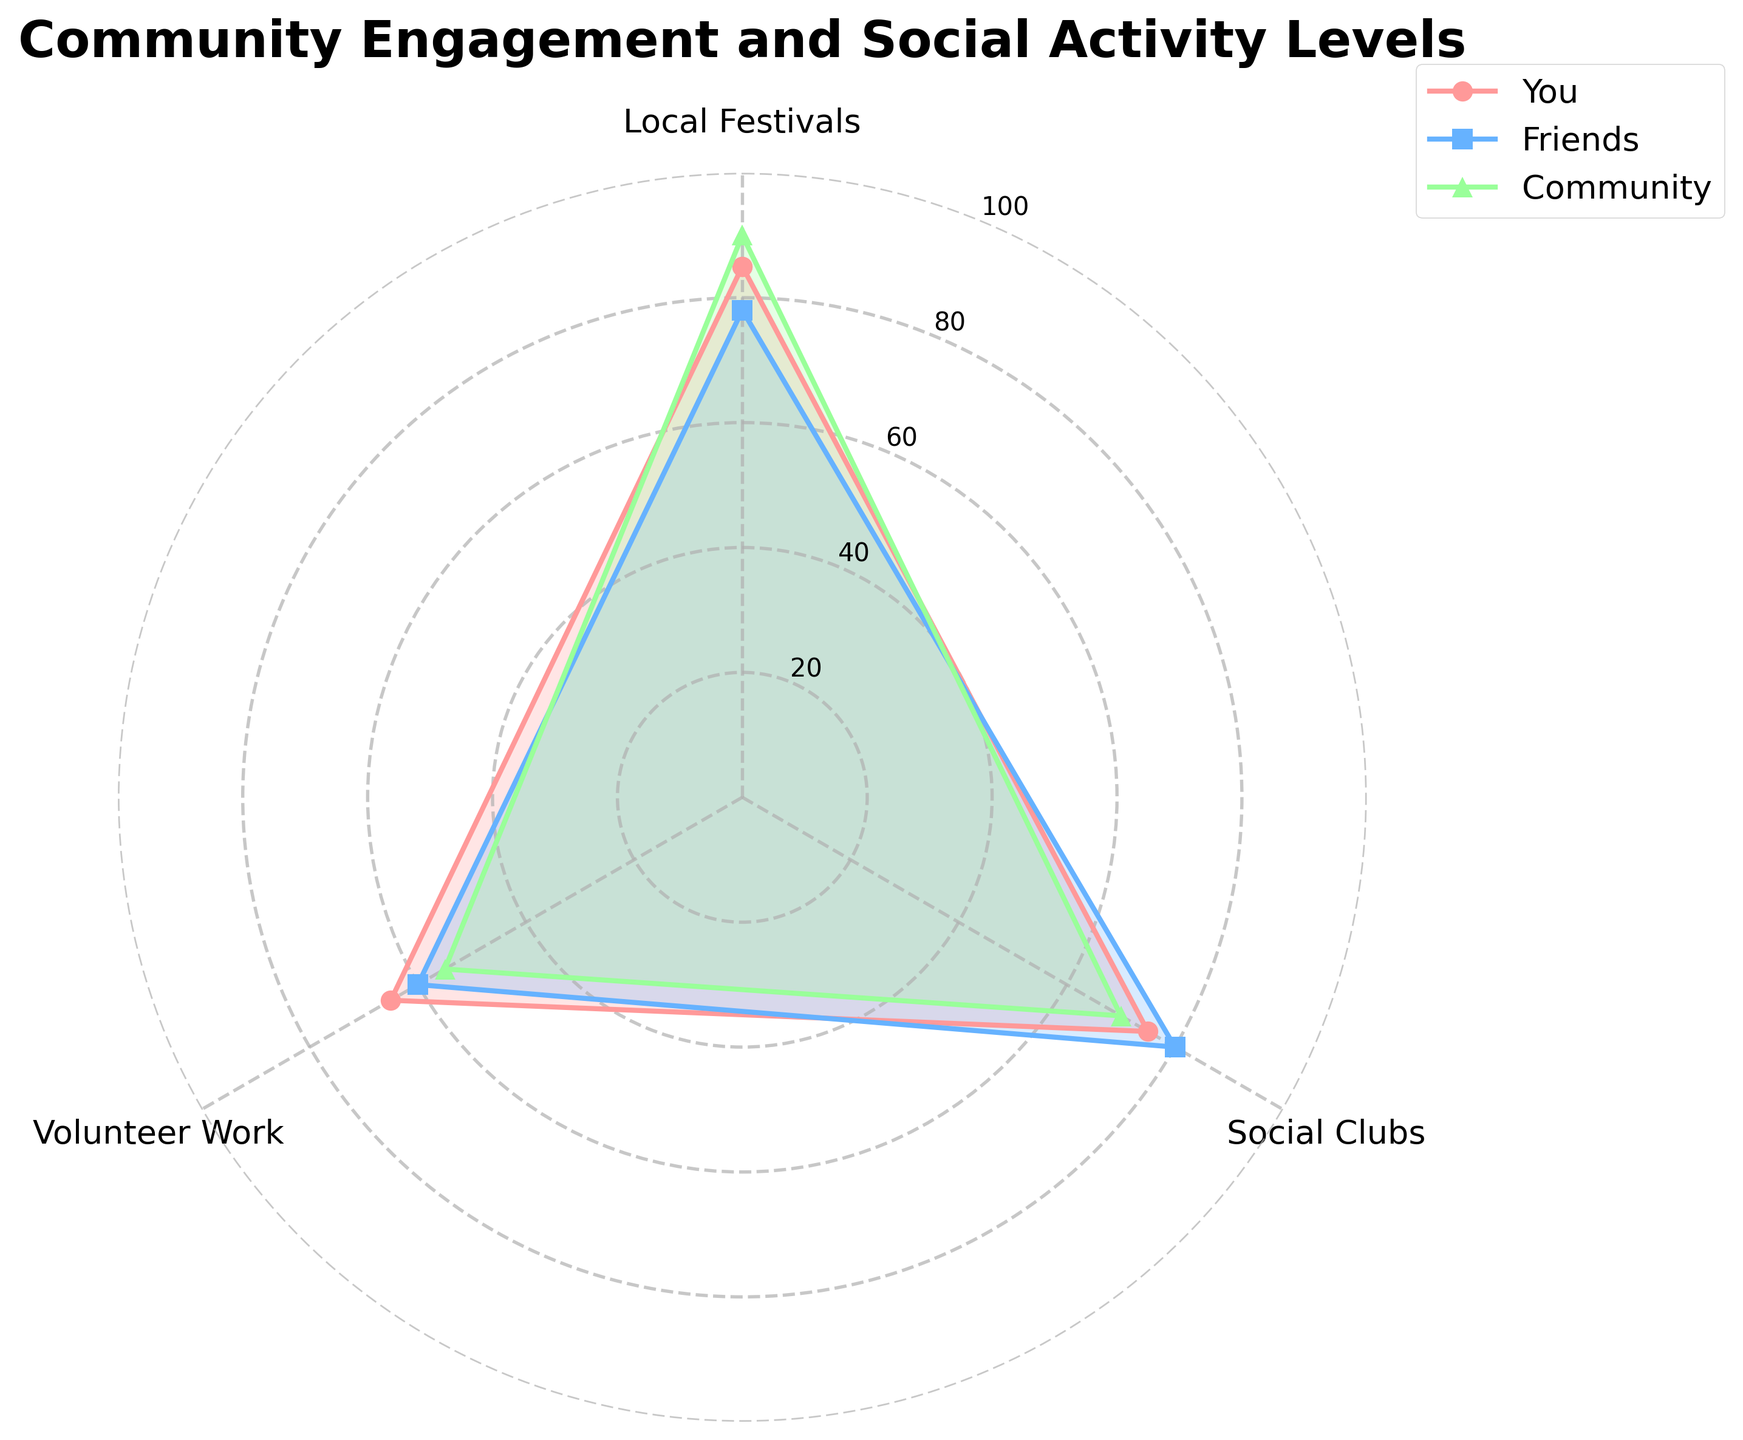What's the title of the chart? The title of the chart is displayed at the top of the figure. In this radar chart, it reads "Community Engagement and Social Activity Levels."
Answer: Community Engagement and Social Activity Levels What are the three categories measured in the chart? The categories measured in the chart are indicated around the radar chart. They are "Local Festivals," "Social Clubs," and "Volunteer Work."
Answer: Local Festivals, Social Clubs, Volunteer Work Which category has the highest participation for "You"? To determine which category has the highest participation for "You," look at the values plotted for "You" in each category. The highest value for "You" is in "Local Festivals," which is 85.
Answer: Local Festivals What is the average participation score for the Community across all categories? Calculate the average by summing the Community scores for each category and dividing by the number of categories: (90 + 70 + 55) / 3 = 71.67.
Answer: 71.67 Is the participation in "Volunteer Work" for Friends greater than for You? Compare the values of "Volunteer Work" between Friends (60) and You (65). Friends' score is less than that of You.
Answer: No Which group has the lowest participation in "Social Clubs"? Look at the participation values for "Social Clubs" for each group. You: 75, Friends: 80, and Community: 70. The lowest is Community.
Answer: Community How does the participation in "Local Festivals" for Friends compare to Community? Compare the values for "Local Festivals" for Friends (78) and Community (90). The Friends' score is lower than that of Community.
Answer: Lower Which group shows the most consistent participation across all categories? Evaluate the range of values for each group. You: 85-65=20, Friends: 80-60=20, Community: 90-55=35. Both You and Friends have the most consistent participation with a range of 20.
Answer: You and Friends What is the difference in participation in "Volunteer Work" between You and Community? Calculate the difference by subtracting the Community score from the You score: 65 - 55 = 10.
Answer: 10 Among all categories, which group has the highest single participation score? Look for the highest single value in the dataset for all groups and categories. The highest value is for Community in "Local Festivals" with a score of 90.
Answer: Community in Local Festivals 